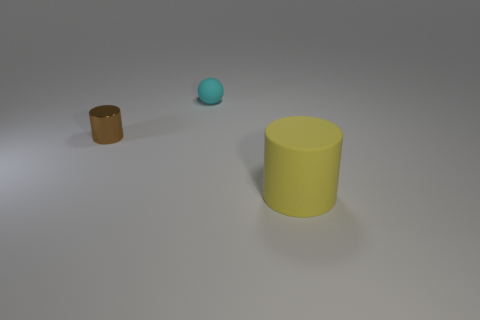What size is the rubber object that is behind the object that is to the right of the tiny ball?
Your answer should be compact. Small. What material is the object that is the same size as the cyan sphere?
Ensure brevity in your answer.  Metal. There is a tiny matte object; are there any tiny cylinders on the right side of it?
Offer a very short reply. No. Are there an equal number of big yellow things that are behind the yellow thing and purple metal cylinders?
Keep it short and to the point. Yes. What shape is the other object that is the same size as the metallic thing?
Your answer should be compact. Sphere. What is the big thing made of?
Provide a succinct answer. Rubber. What color is the thing that is both behind the yellow cylinder and on the right side of the brown metal thing?
Offer a terse response. Cyan. Is the number of rubber things on the right side of the cyan rubber object the same as the number of cylinders right of the brown thing?
Keep it short and to the point. Yes. There is a tiny sphere that is the same material as the big yellow thing; what color is it?
Provide a succinct answer. Cyan. There is a matte thing that is to the right of the rubber thing to the left of the yellow rubber cylinder; are there any cyan objects in front of it?
Provide a short and direct response. No. 